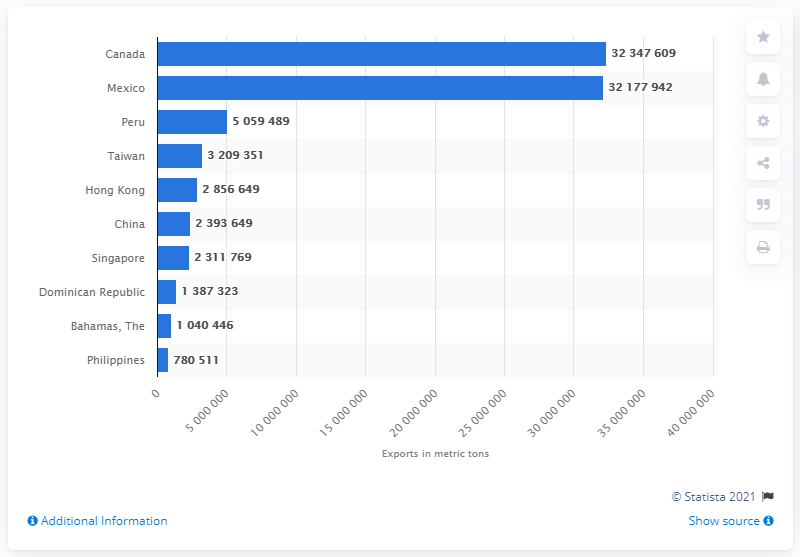Point out several critical features in this image. In 2013, the United States exported 32,347,609 liters of fluid milk and cream to Canada. 